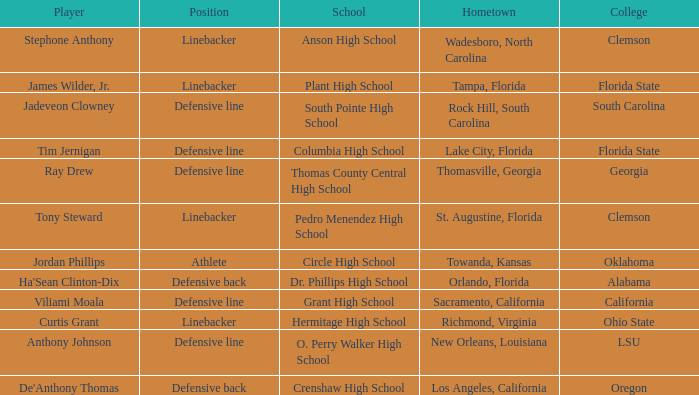What position is for Dr. Phillips high school? Defensive back. 